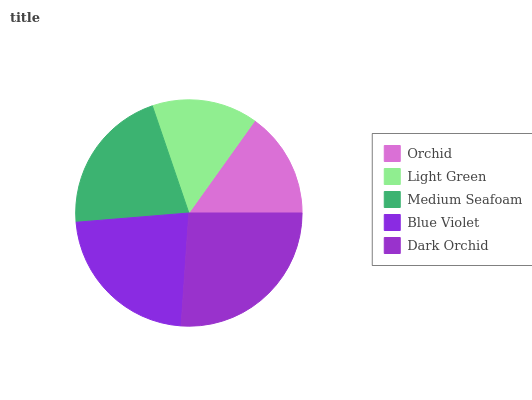Is Light Green the minimum?
Answer yes or no. Yes. Is Dark Orchid the maximum?
Answer yes or no. Yes. Is Medium Seafoam the minimum?
Answer yes or no. No. Is Medium Seafoam the maximum?
Answer yes or no. No. Is Medium Seafoam greater than Light Green?
Answer yes or no. Yes. Is Light Green less than Medium Seafoam?
Answer yes or no. Yes. Is Light Green greater than Medium Seafoam?
Answer yes or no. No. Is Medium Seafoam less than Light Green?
Answer yes or no. No. Is Medium Seafoam the high median?
Answer yes or no. Yes. Is Medium Seafoam the low median?
Answer yes or no. Yes. Is Dark Orchid the high median?
Answer yes or no. No. Is Blue Violet the low median?
Answer yes or no. No. 